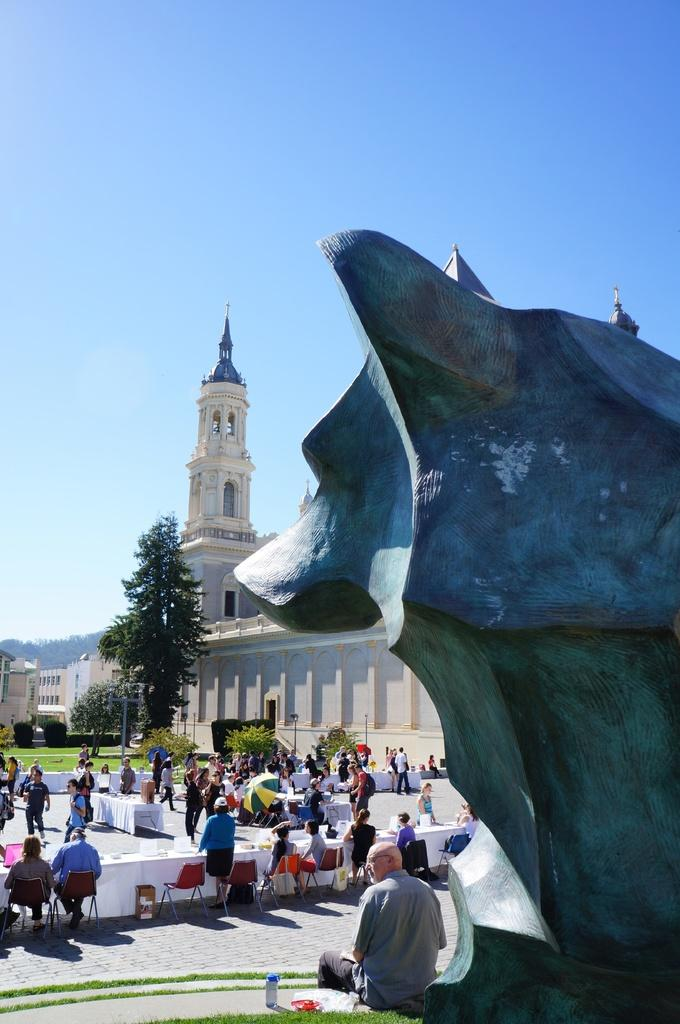What are the people in the image doing? The people in the image are sitting on chairs. Can you describe the location of the person near a statue? There is a person sitting near a statue in the image. What type of natural elements can be seen in the image? There are trees in the image. What type of man-made structures are visible in the image? There are buildings in the image. What is the condition of the sky in the image? The sky is clear in the image. How many beads are hanging from the statue in the image? There is no mention of beads in the image, and no beads are visible. 